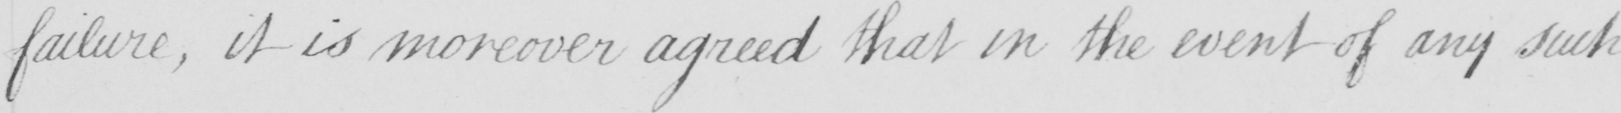Transcribe the text shown in this historical manuscript line. failure , it is moreover agreed that in the event of any such 